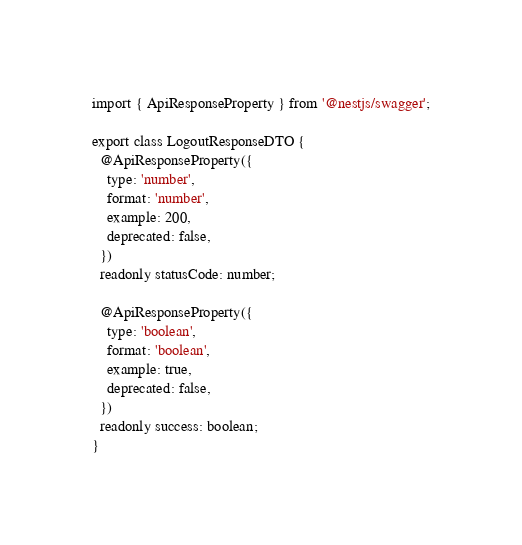<code> <loc_0><loc_0><loc_500><loc_500><_TypeScript_>import { ApiResponseProperty } from '@nestjs/swagger';

export class LogoutResponseDTO {
  @ApiResponseProperty({
    type: 'number',
    format: 'number',
    example: 200,
    deprecated: false,
  })
  readonly statusCode: number;

  @ApiResponseProperty({
    type: 'boolean',
    format: 'boolean',
    example: true,
    deprecated: false,
  })
  readonly success: boolean;
}
</code> 